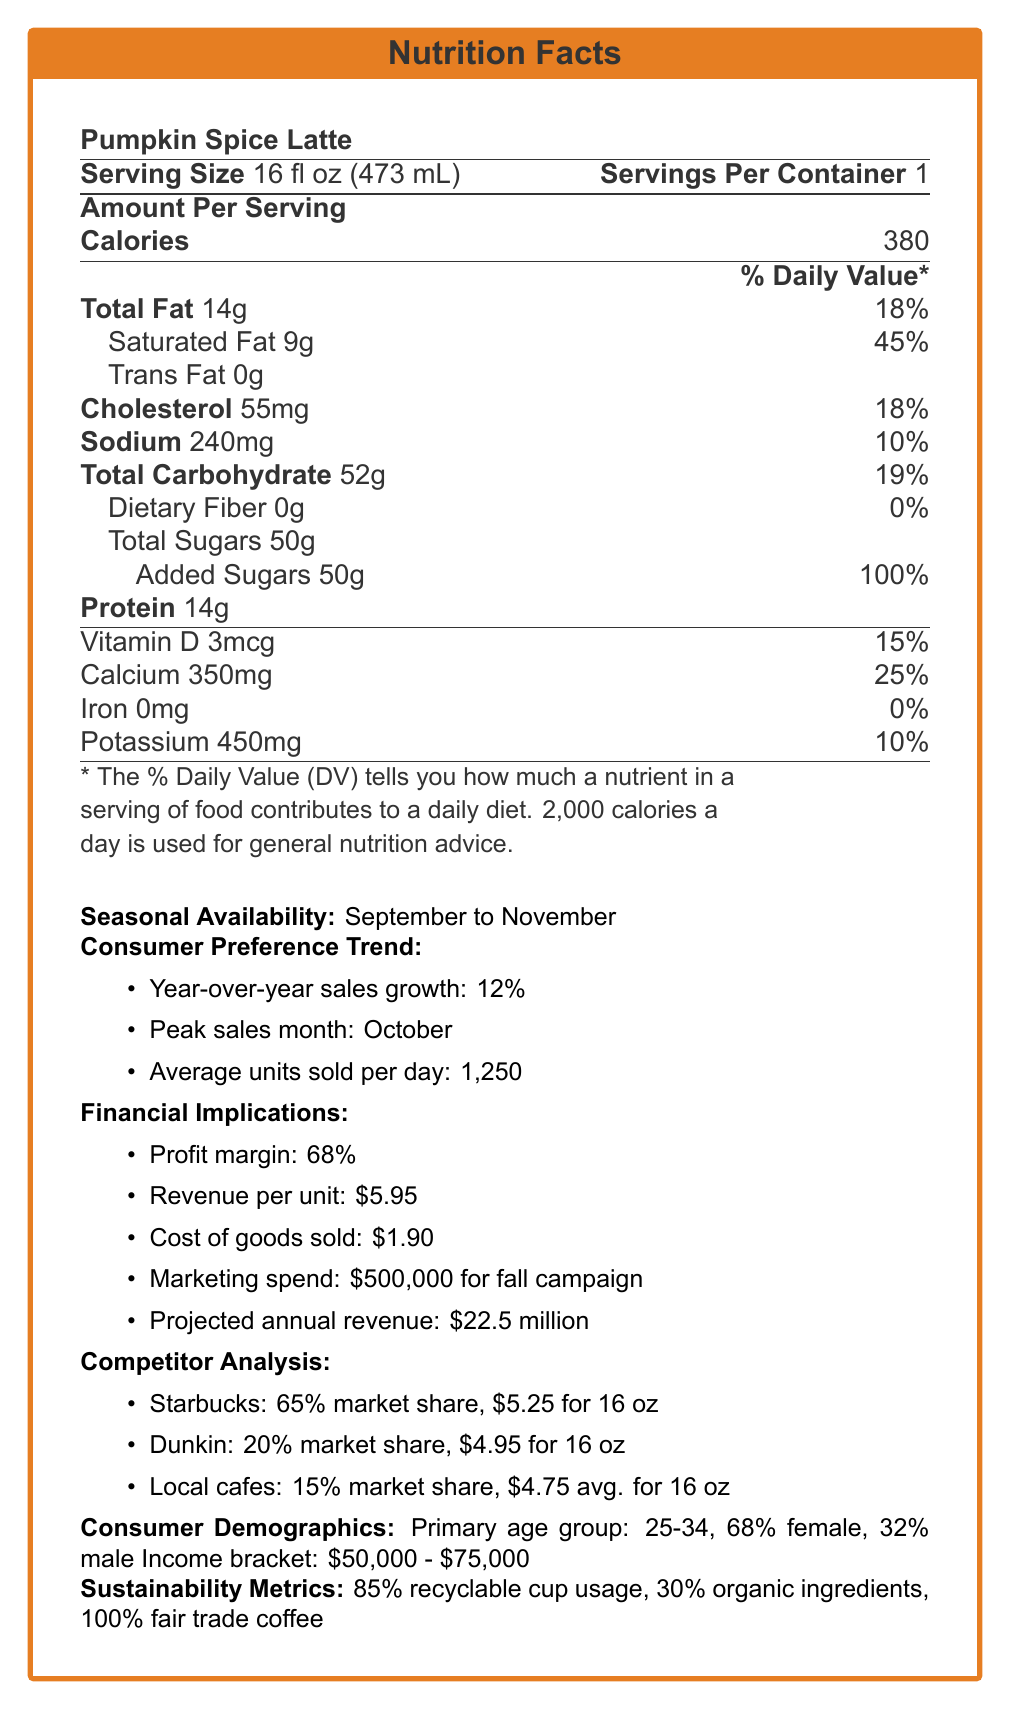What is the serving size of a Pumpkin Spice Latte? The document specifies the serving size as 16 fl oz (473 mL).
Answer: 16 fl oz (473 mL) How many calories are in one serving of Pumpkin Spice Latte? According to the Nutrition Facts, one serving contains 380 calories.
Answer: 380 What is the peak sales month for the Pumpkin Spice Latte? The document indicates that the peak sales month for the Pumpkin Spice Latte is October.
Answer: October What is the profit margin for the Pumpkin Spice Latte? The document lists the profit margin as 68%.
Answer: 68% How much revenue is generated per unit of Pumpkin Spice Latte? It's specified in the document that the revenue per unit is $5.95.
Answer: $5.95 What is the total fat content in a serving of Pumpkin Spice Latte and its percentage of daily value? The document states the total fat content as 14g and the daily value as 18%.
Answer: 14g, 18% Which competitor has the largest market share for a similar product? A. Starbucks B. Dunkin C. Local cafes The document states that Starbucks has the largest market share at 65%.
Answer: A, Starbucks What is the primary age group of consumers for the Pumpkin Spice Latte? A. 18-24 B. 25-34 C. 35-44 D. 45+ The document indicates that the primary age group is 25-34.
Answer: B, 25-34 Has the cost of cinnamon increased year-over-year? The document specifies that the cost of cinnamon has decreased by 2% year-over-year.
Answer: No Is the Pumpkin Spice Latte made with 100% fair trade coffee? The document mentions that their fair trade coffee sourcing is 100%.
Answer: Yes Summarize the main content of the document. The document outlines essential nutritional information such as calories and fat content, sales trends and consumer preferences, competitor pricing, demographics of the main consumer base, and sustainability commitments.
Answer: The document provides detailed nutrition facts for a Pumpkin Spice Latte, its seasonal availability, consumer preference trends, financial implications including profit margin and revenue per unit, competitor analysis, consumer demographics, and sustainability metrics. What is the exact amount of dietary fiber in a serving of Pumpkin Spice Latte? The document clearly states that there are 0g of dietary fiber in one serving of Pumpkin Spice Latte.
Answer: 0g Which ingredient has experienced the highest cost fluctuation year-over-year? A. Pumpkin Puree B. Cinnamon C. Nutmeg D. Milk The document mentions that nutmeg has experienced a cost increase of 8%.
Answer: C, Nutmeg What is the marketing spend for the fall campaign? According to the document, the marketing spend for the fall campaign is $500,000.
Answer: $500,000 How much calcium is in one serving of Pumpkin Spice Latte? The document lists the calcium content as 350mg, which is 25% of the daily value.
Answer: 350mg (25% of daily value) What is the average number of units sold per day for the Pumpkin Spice Latte? The document states that the average units sold per day are 1,250.
Answer: 1,250 What is the revenue per unit for Starbucks' similar product? The document specifies that the price for Starbucks' similar product is $5.25.
Answer: $5.25 How much marketing spend is allocated for the entire annual campaign? The document only provides the marketing spend for the fall campaign, not the entire year.
Answer: Not enough information 